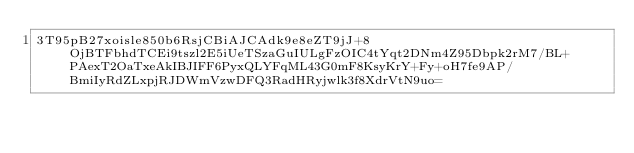<code> <loc_0><loc_0><loc_500><loc_500><_SML_>3T95pB27xoisle850b6RsjCBiAJCAdk9e8eZT9jJ+8OjBTFbhdTCEi9tszl2E5iUeTSzaGuIULgFzOIC4tYqt2DNm4Z95Dbpk2rM7/BL+PAexT2OaTxeAkIBJIFF6PyxQLYFqML43G0mF8KsyKrY+Fy+oH7fe9AP/BmiIyRdZLxpjRJDWmVzwDFQ3RadHRyjwlk3f8XdrVtN9uo=</code> 